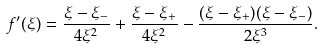Convert formula to latex. <formula><loc_0><loc_0><loc_500><loc_500>f ^ { \prime } ( \xi ) = \frac { \xi - \xi _ { - } } { 4 \xi ^ { 2 } } + \frac { \xi - \xi _ { + } } { 4 \xi ^ { 2 } } - \frac { ( \xi - \xi _ { + } ) ( \xi - \xi _ { - } ) } { 2 \xi ^ { 3 } } .</formula> 